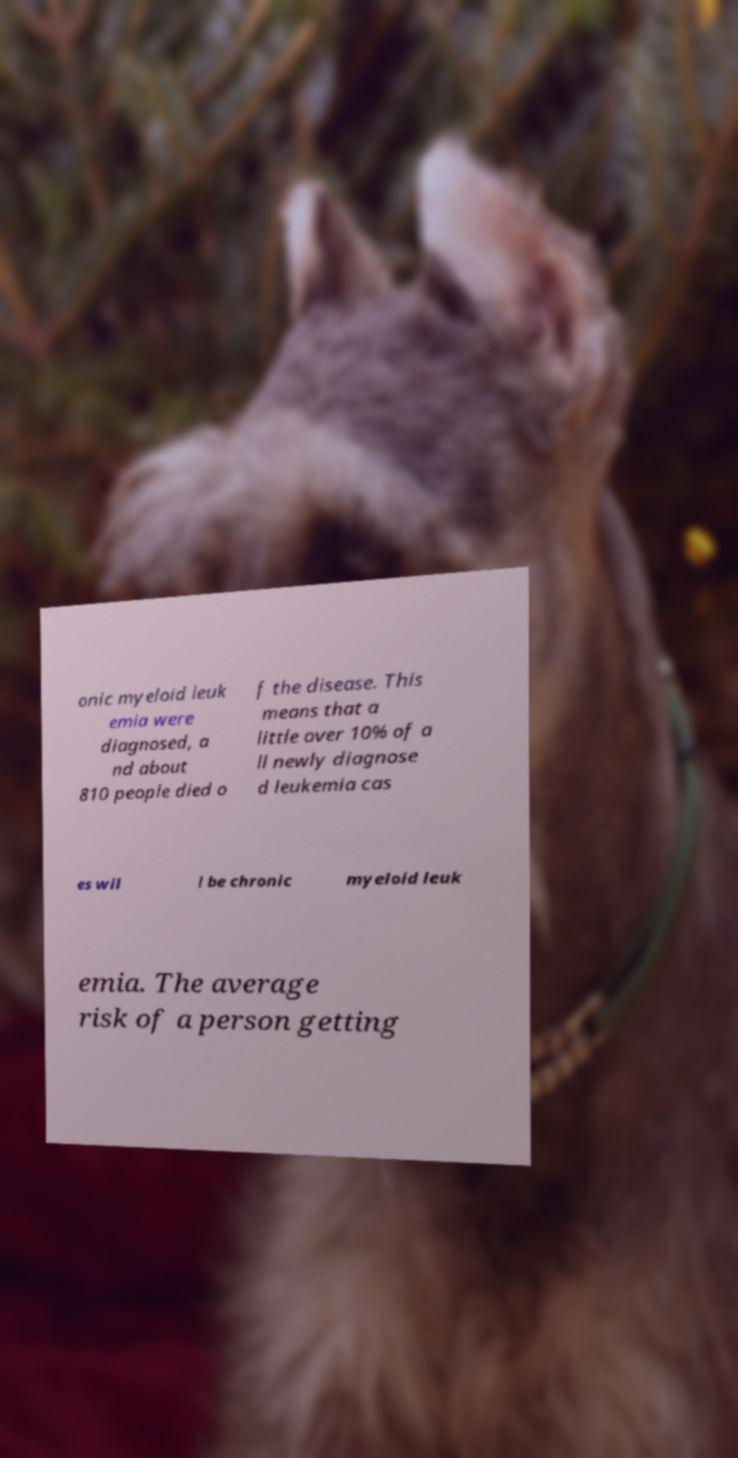Could you extract and type out the text from this image? onic myeloid leuk emia were diagnosed, a nd about 810 people died o f the disease. This means that a little over 10% of a ll newly diagnose d leukemia cas es wil l be chronic myeloid leuk emia. The average risk of a person getting 